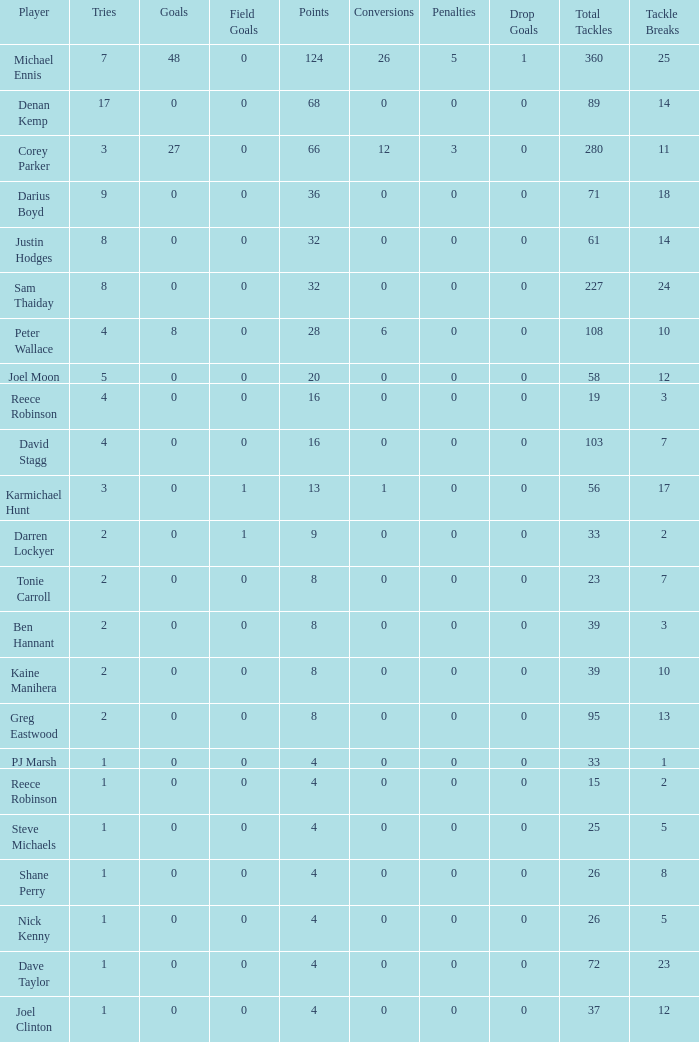How many points did the player with 2 tries and more than 0 field goals have? 9.0. 